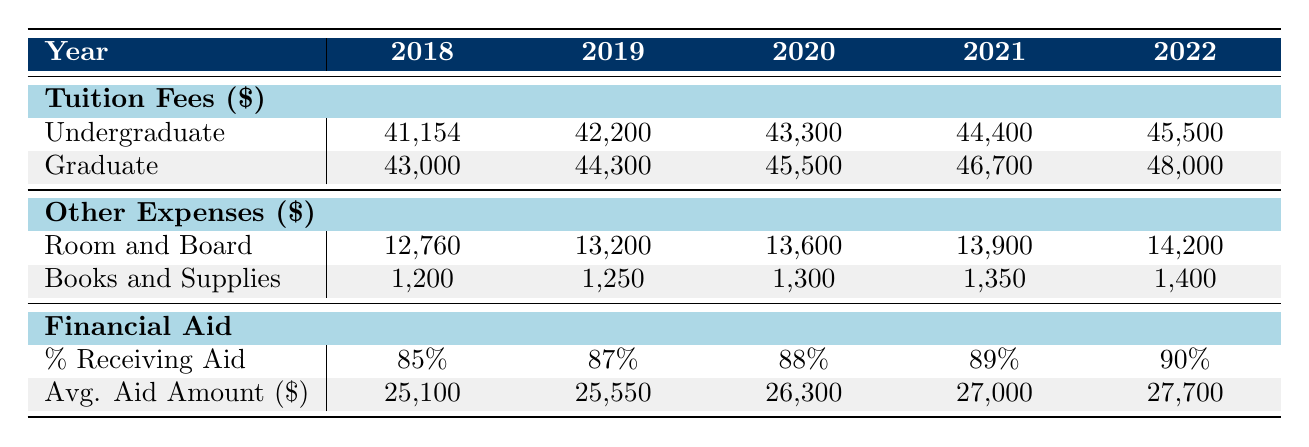What was the undergraduate tuition fee in 2020? The table shows the undergraduate tuition fees for each year. For 2020, the value listed is 43,300.
Answer: 43,300 What was the increase in room and board from 2018 to 2022? To find the increase, subtract the room and board amount in 2018 from the amount in 2022: 14,200 - 12,760 = 1,440.
Answer: 1,440 What percentage of students received financial aid in 2021? The table indicates that in 2021, the percentage of students receiving financial aid is 89%.
Answer: 89% Is the average financial aid amount in 2019 higher than in 2018? Comparing the average financial aid amounts, in 2018 it was 25,100, and in 2019 it was 25,550. Since 25,550 is higher than 25,100, the statement is true.
Answer: Yes What is the average undergraduate tuition fee over the five years from 2018 to 2022? To calculate the average, sum the undergraduate tuition fees: (41,154 + 42,200 + 43,300 + 44,400 + 45,500) = 216,554. Then divide by 5 to find the average: 216,554 / 5 = 43,310.8.
Answer: 43,310.8 What was the total amount for books and supplies in 2020 and 2021 combined? To find the total, add the amounts for books and supplies for both years: 1,300 (2020) + 1,350 (2021) = 2,650.
Answer: 2,650 Did the percentage of students receiving financial aid increase every year from 2018 to 2022? By examining the data, the percentages are 85% (2018), 87% (2019), 88% (2020), 89% (2021), and 90% (2022). Since they all increased, the statement is true.
Answer: Yes What is the difference between the graduate tuition fees in 2020 and 2022? To find the difference, subtract the graduate tuition fee for 2020 from that for 2022: 48,000 - 45,500 = 2,500.
Answer: 2,500 What is the highest average financial aid amount recorded in the last five years? The table shows average financial aid amounts for each year: 25,100, 25,550, 26,300, 27,000, and 27,700. The highest value is 27,700 for 2022.
Answer: 27,700 